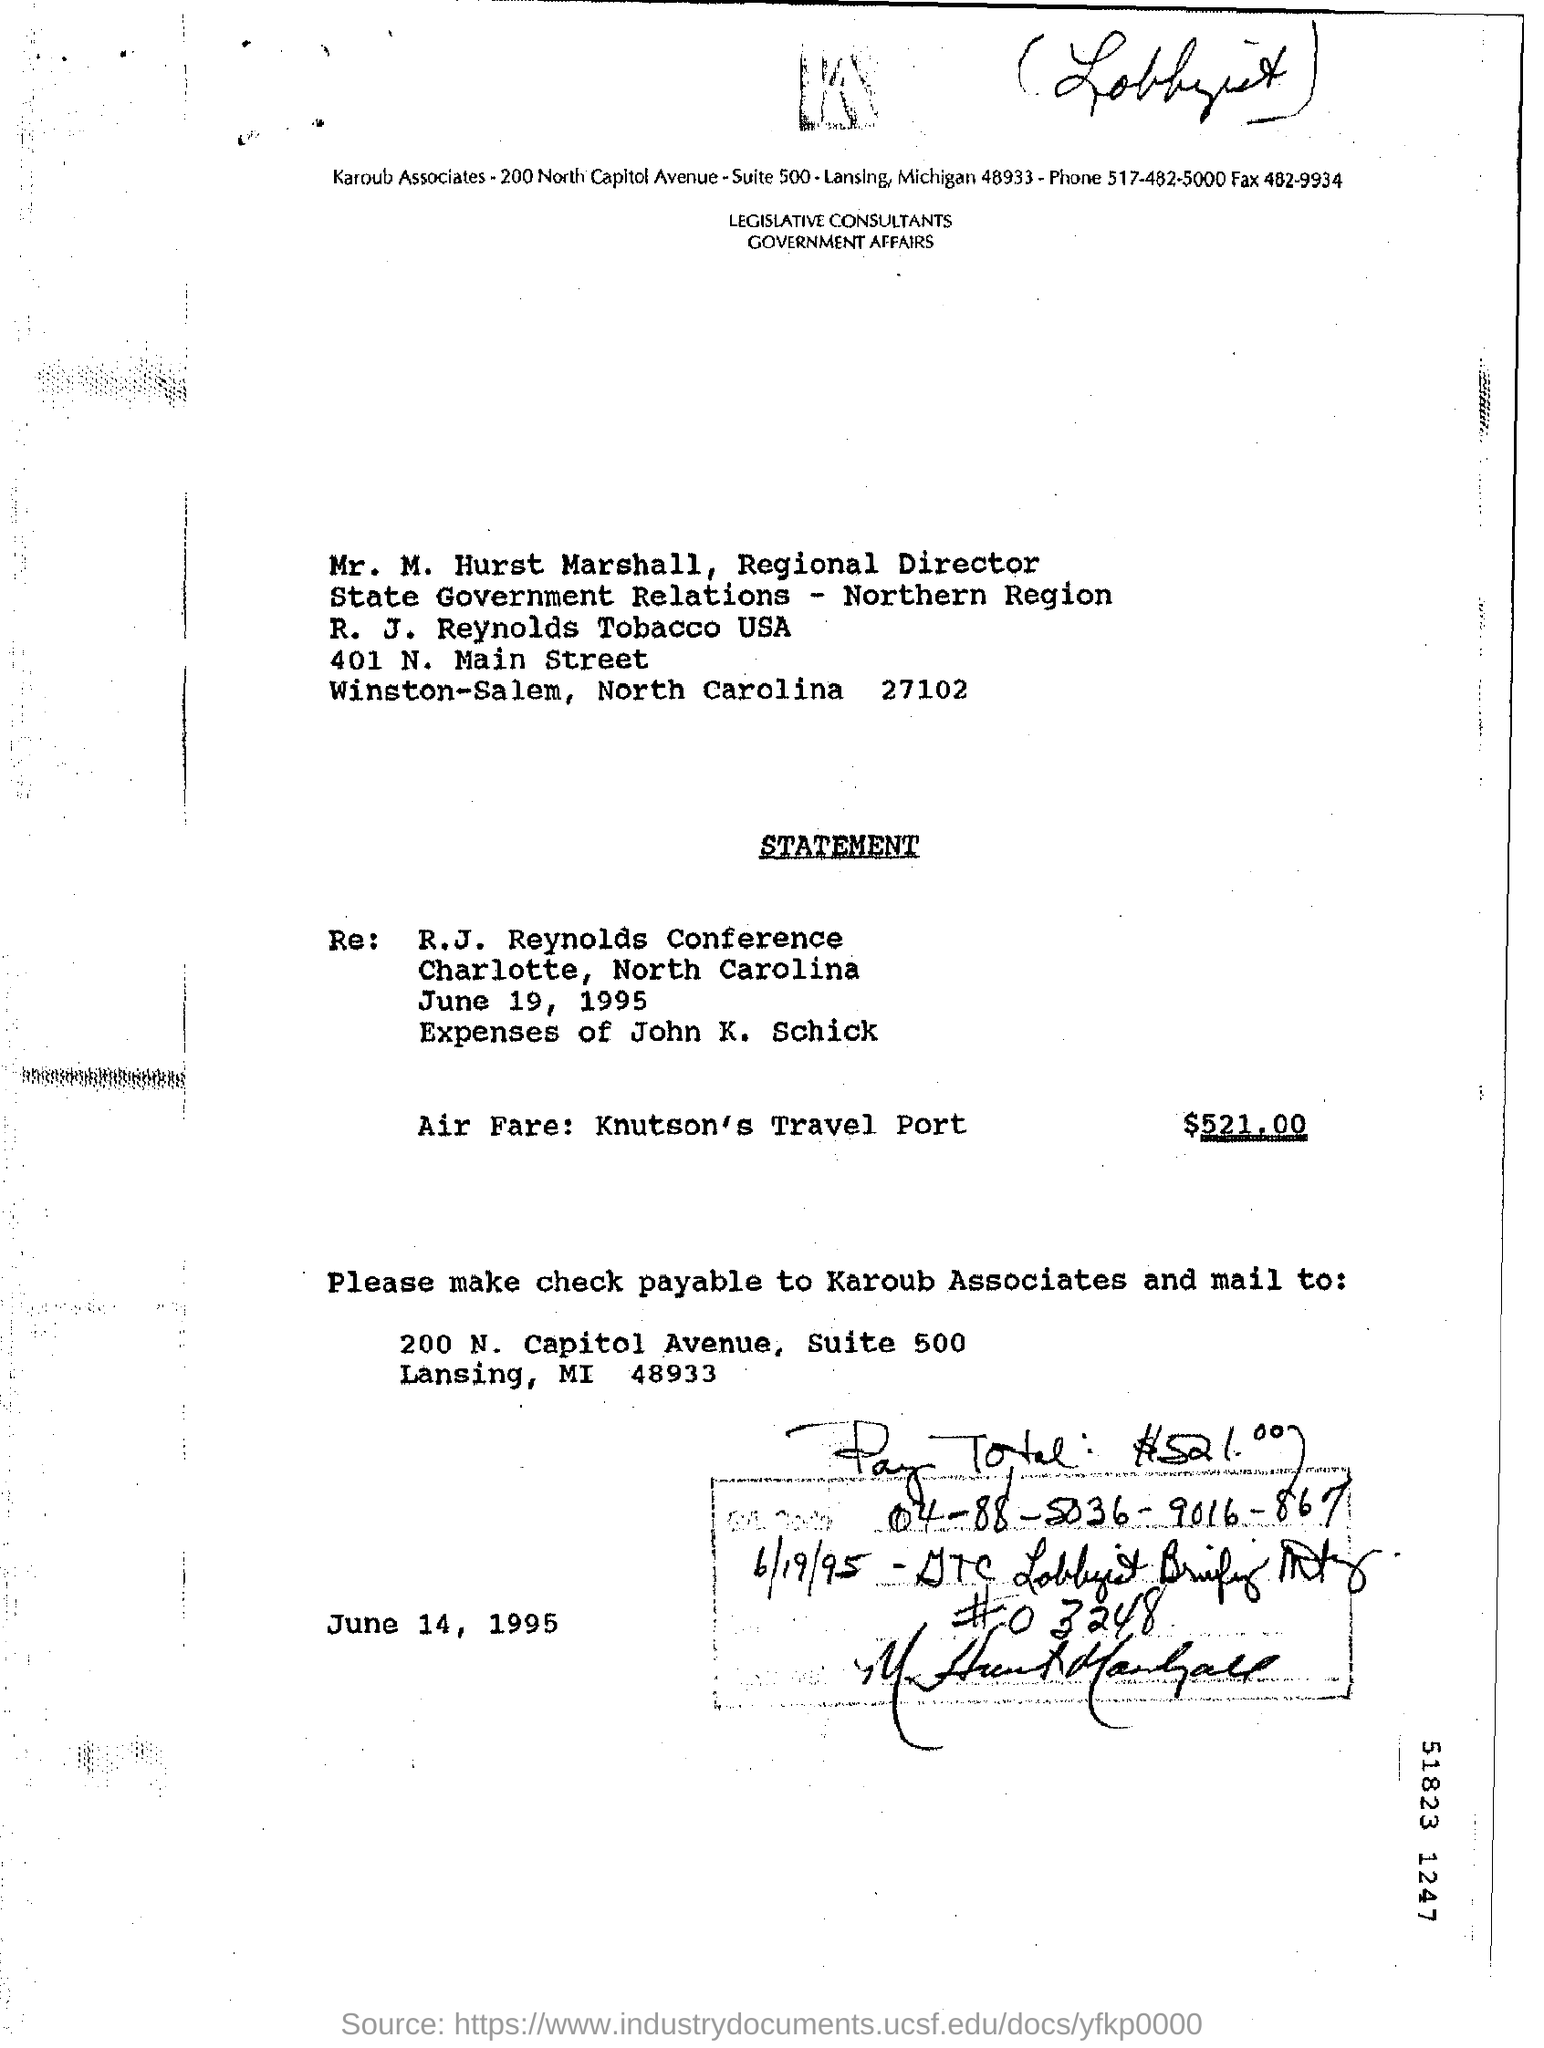How much is the air fare?
Keep it short and to the point. 521.00. Whom is the check payable to?
Provide a short and direct response. Karoub Associates. When is the letter dated?
Ensure brevity in your answer.  June 14, 1995. 